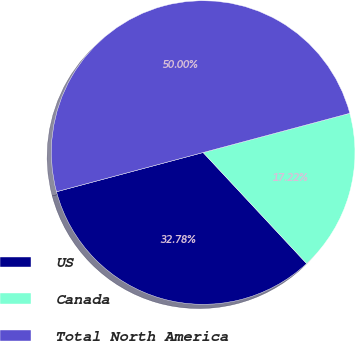Convert chart to OTSL. <chart><loc_0><loc_0><loc_500><loc_500><pie_chart><fcel>US<fcel>Canada<fcel>Total North America<nl><fcel>32.78%<fcel>17.22%<fcel>50.0%<nl></chart> 